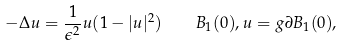<formula> <loc_0><loc_0><loc_500><loc_500>- \Delta u = \frac { 1 } { \epsilon ^ { 2 } } u ( 1 - | u | ^ { 2 } ) \quad B _ { 1 } ( 0 ) , u = g \partial B _ { 1 } ( 0 ) ,</formula> 